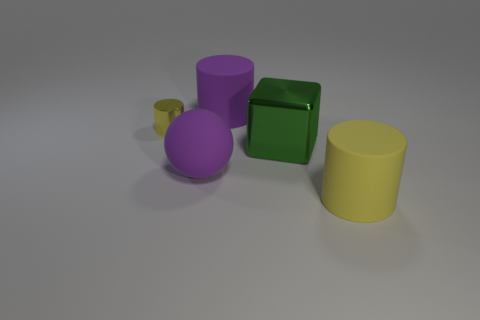Add 2 large yellow cylinders. How many objects exist? 7 Subtract all large cylinders. How many cylinders are left? 1 Subtract all yellow cylinders. How many cylinders are left? 1 Subtract all cylinders. How many objects are left? 2 Subtract 0 gray balls. How many objects are left? 5 Subtract all purple cubes. Subtract all yellow balls. How many cubes are left? 1 Subtract all gray blocks. How many yellow cylinders are left? 2 Subtract all large green metal blocks. Subtract all big cylinders. How many objects are left? 2 Add 1 green metal things. How many green metal things are left? 2 Add 3 large purple cylinders. How many large purple cylinders exist? 4 